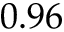<formula> <loc_0><loc_0><loc_500><loc_500>0 . 9 6</formula> 